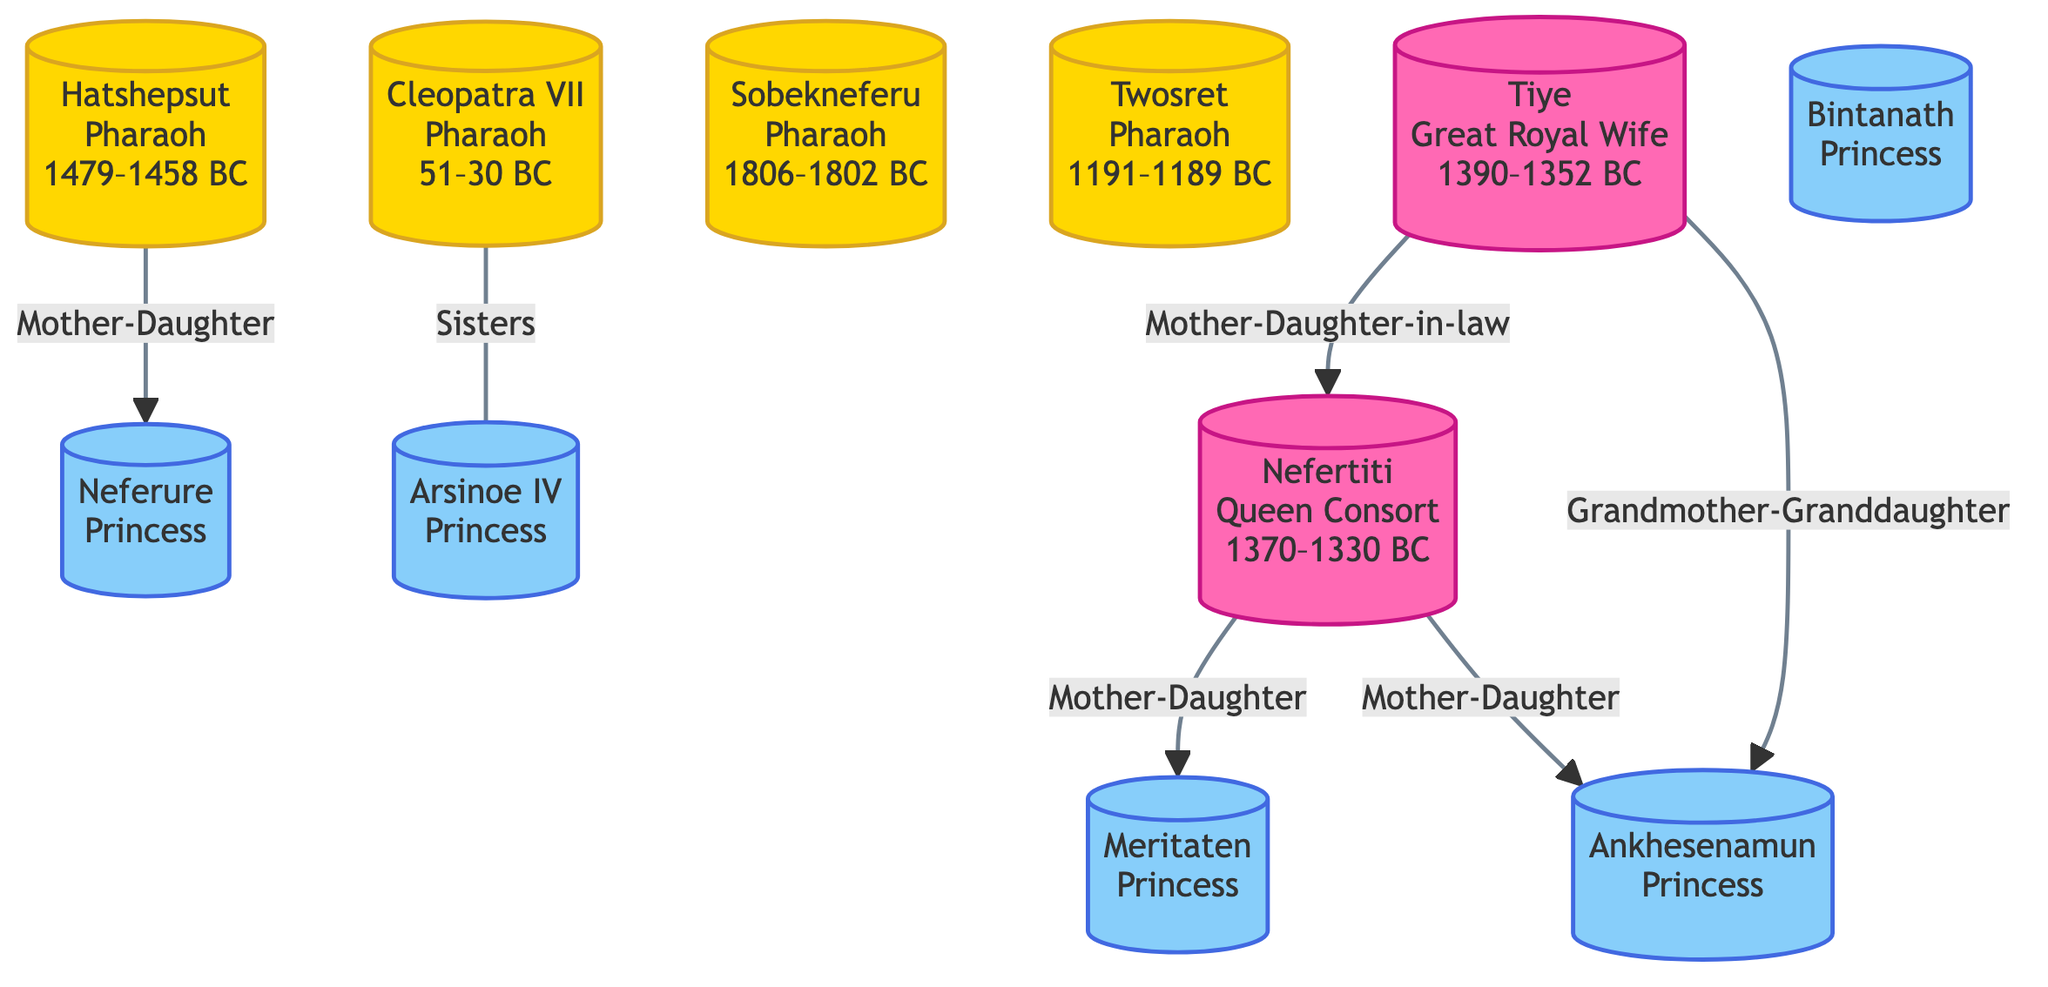What is the reign period of Hatshepsut? Hatshepsut is identified by the node with an ID of 1, and her reign period is specifically indicated as 1479–1458 BC.
Answer: 1479–1458 BC How many daughters did Nefertiti have according to the diagram? Nefertiti, shown in node ID 3, has two daughters listed: Meritaten (ID 4) and Ankhesenamun (ID 10). Thus, there are two connections describing her relationship as Mother-Daughter.
Answer: 2 What is the relationship between Cleopatra VII and Arsinoe IV? Cleopatra VII (ID 5) and Arsinoe IV (ID 6) are connected by the "Sisters" relationship, indicated by the connection between these two nodes.
Answer: Sisters Who is the grandmother of Ankhesenamun? Ankhesenamun (ID 10) is linked through a "Grandmother-Granddaughter" relationship to Tiye (ID 9), who is identified as her grandmother in the diagram.
Answer: Tiye Which Pharaoh ruled after Sobekneferu? Completing an analysis of the nodes reveals that Sobekneferu (ID 7) does not have a specified successor visible in this diagram, and no connections indicate succession. Therefore, it's unclear from the diagram.
Answer: N/A Identify the role of Meritaten. Meritaten, indicated by node ID 4, is labeled as a "Princess," which is defined within her node details.
Answer: Princess How many Pharaohs are present in the diagram? The diagram identifies four individuals with the role of Pharaoh: Hatshepsut (ID 1), Cleopatra VII (ID 5), Sobekneferu (ID 7), and Twosret (ID 8). Thus, the count of Pharaohs in the diagram is calculated from the nodes fulfilling this role.
Answer: 4 What type of diagram is presented? The visual structure identifies this as a Network Diagram, showcasing relationships among various historical figures. This is inferred from the way nodes and links are arranged to demonstrate connections.
Answer: Network Diagram 